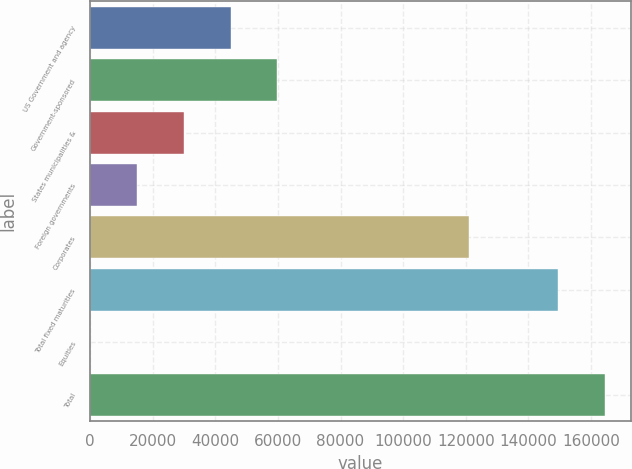<chart> <loc_0><loc_0><loc_500><loc_500><bar_chart><fcel>US Government and agency<fcel>Government-sponsored<fcel>States municipalities &<fcel>Foreign governments<fcel>Corporates<fcel>Total fixed maturities<fcel>Equities<fcel>Total<nl><fcel>44887.4<fcel>59849.5<fcel>29925.4<fcel>14963.3<fcel>121087<fcel>149622<fcel>1.21<fcel>164584<nl></chart> 